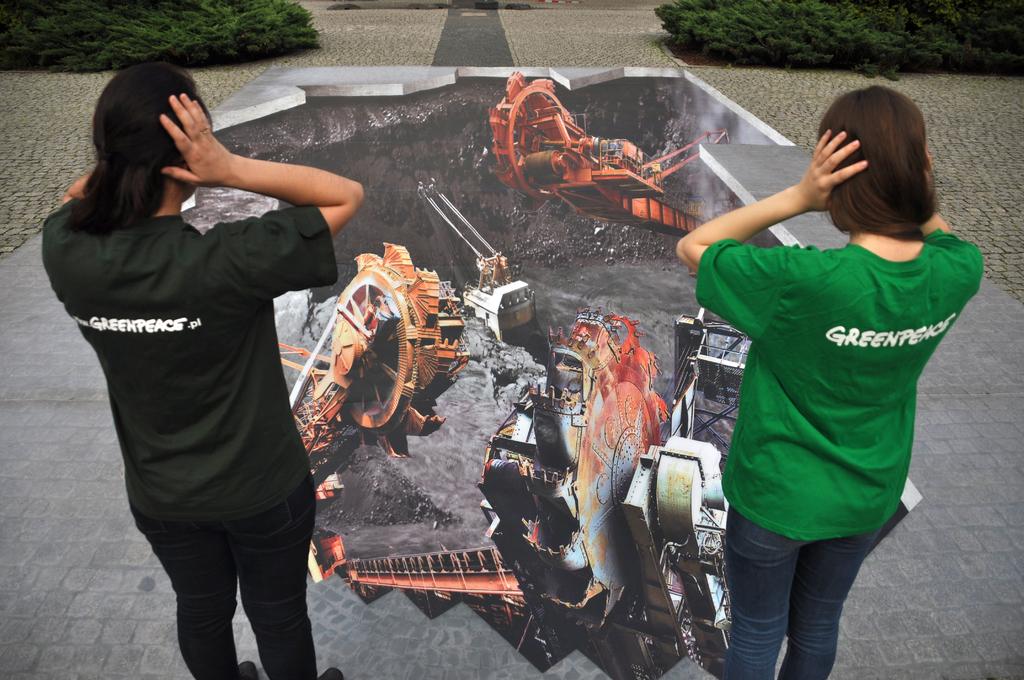What is on the back of the green shirt?
Your answer should be compact. Greenpeace. Are the women wearing greenpeace shirts?
Ensure brevity in your answer.  Yes. 